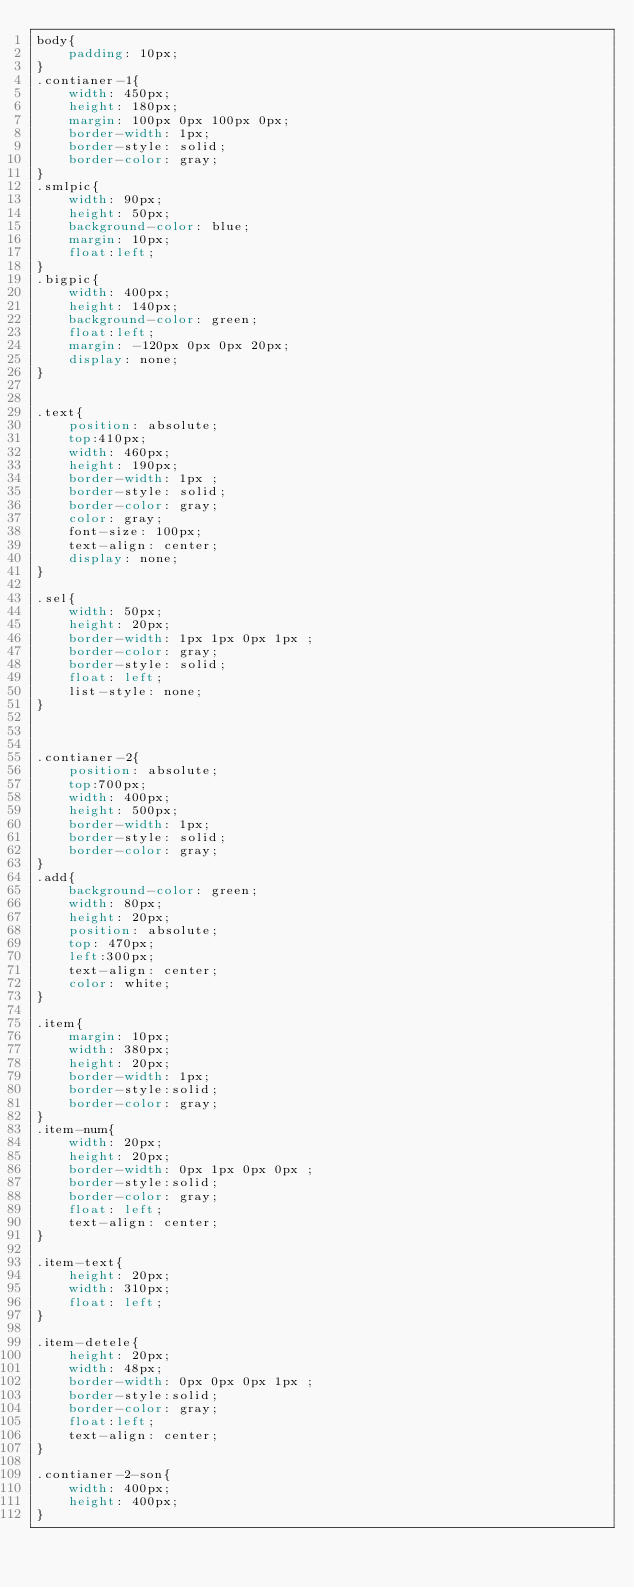<code> <loc_0><loc_0><loc_500><loc_500><_CSS_>body{
	padding: 10px;
}
.contianer-1{
	width: 450px;
	height: 180px;
	margin: 100px 0px 100px 0px;
	border-width: 1px;
	border-style: solid;
	border-color: gray;
}
.smlpic{
	width: 90px;
	height: 50px;
	background-color: blue;
	margin: 10px;
	float:left;
}
.bigpic{
	width: 400px;
	height: 140px;
	background-color: green;
	float:left;
	margin: -120px 0px 0px 20px;
	display: none;
}


.text{
	position: absolute;
	top:410px;
	width: 460px;
	height: 190px;
	border-width: 1px ;
	border-style: solid;
	border-color: gray;
	color: gray;
	font-size: 100px;
	text-align: center;
	display: none;
}

.sel{
	width: 50px;
	height: 20px;
	border-width: 1px 1px 0px 1px ;
	border-color: gray;
	border-style: solid;
	float: left;
	list-style: none;
}



.contianer-2{
	position: absolute;
	top:700px;
	width: 400px;
	height: 500px;
	border-width: 1px;
	border-style: solid;
	border-color: gray;
}
.add{
	background-color: green;
	width: 80px;
	height: 20px;
	position: absolute;
	top: 470px;
	left:300px;
	text-align: center;
	color: white;
}

.item{
	margin: 10px;
	width: 380px;
	height: 20px;
	border-width: 1px;
	border-style:solid;
	border-color: gray;
}
.item-num{
	width: 20px;
	height: 20px;
	border-width: 0px 1px 0px 0px ;
	border-style:solid;
	border-color: gray;
	float: left;
	text-align: center;
}

.item-text{
	height: 20px;
	width: 310px;
	float: left;
}

.item-detele{
	height: 20px;
	width: 48px;
	border-width: 0px 0px 0px 1px ;
	border-style:solid;
	border-color: gray;
	float:left;
	text-align: center;
}

.contianer-2-son{
	width: 400px;
	height: 400px;
}</code> 